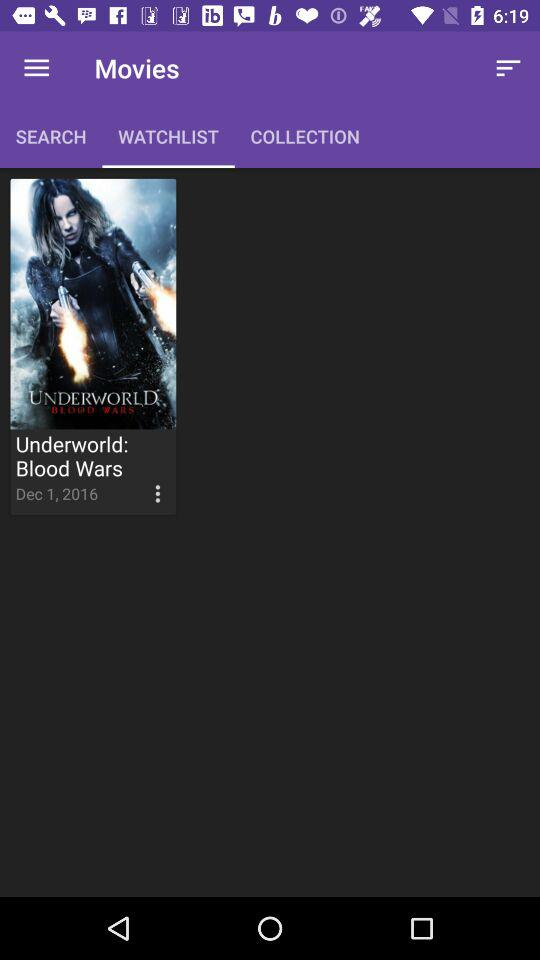What is the name of the movie? The name of the movie is "Underworld: Blood Wars". 